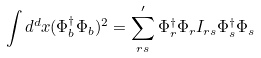Convert formula to latex. <formula><loc_0><loc_0><loc_500><loc_500>\int d ^ { d } x ( \Phi _ { b } ^ { \dagger } \Phi _ { b } ) ^ { 2 } = \sum _ { r s } ^ { \prime } \Phi _ { r } ^ { \dagger } \Phi _ { r } I _ { r s } \Phi _ { s } ^ { \dagger } \Phi _ { s }</formula> 